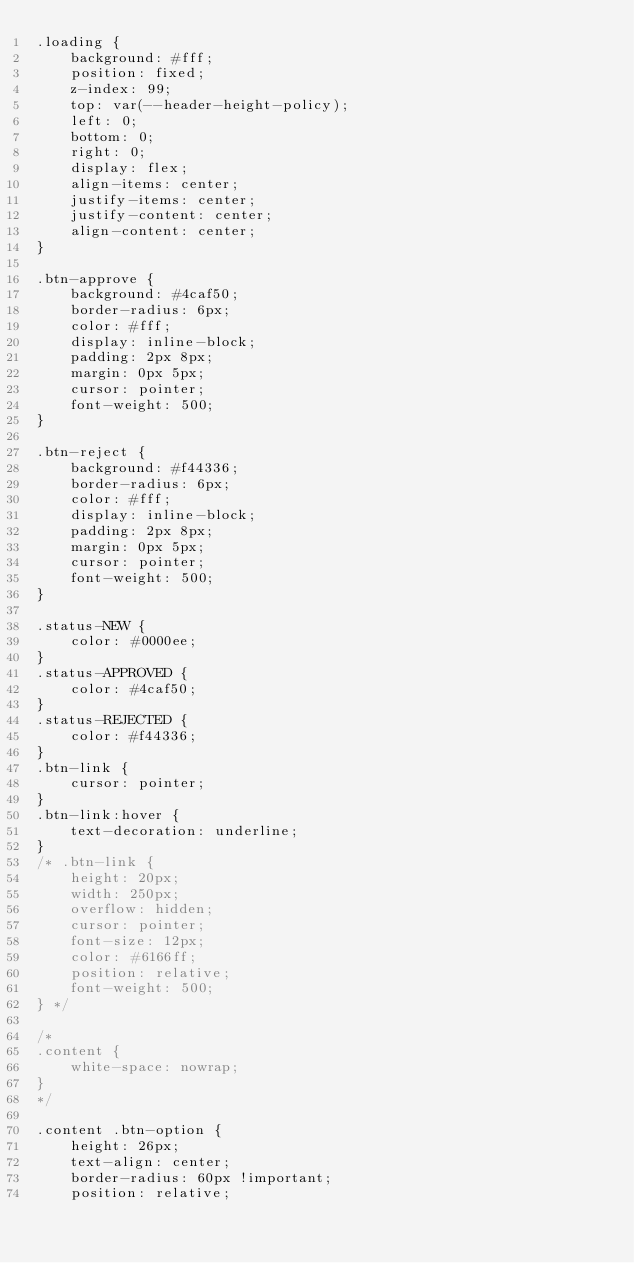Convert code to text. <code><loc_0><loc_0><loc_500><loc_500><_CSS_>.loading {
    background: #fff;
    position: fixed;
    z-index: 99;
    top: var(--header-height-policy);
    left: 0;
    bottom: 0;
    right: 0;
    display: flex;
    align-items: center;
    justify-items: center;
    justify-content: center;
    align-content: center;
}

.btn-approve {
    background: #4caf50;
    border-radius: 6px;
    color: #fff;
    display: inline-block;
    padding: 2px 8px;
    margin: 0px 5px;
    cursor: pointer;
    font-weight: 500;
}

.btn-reject {
    background: #f44336;
    border-radius: 6px;
    color: #fff;
    display: inline-block;
    padding: 2px 8px;
    margin: 0px 5px;
    cursor: pointer;
    font-weight: 500;
}

.status-NEW {
    color: #0000ee;
}
.status-APPROVED {
    color: #4caf50;
}
.status-REJECTED {
    color: #f44336;
}
.btn-link {
    cursor: pointer;
}
.btn-link:hover {
    text-decoration: underline;
}
/* .btn-link {
    height: 20px;
    width: 250px;
    overflow: hidden;
    cursor: pointer;
    font-size: 12px;
    color: #6166ff;
    position: relative;
    font-weight: 500;
} */

/*
.content {
    white-space: nowrap;
}
*/

.content .btn-option {
    height: 26px;
    text-align: center;
    border-radius: 60px !important;
    position: relative;</code> 